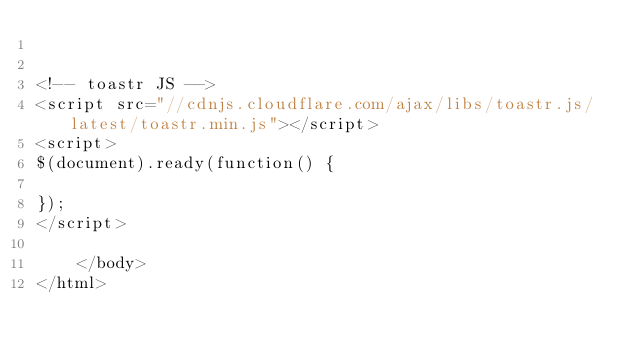Convert code to text. <code><loc_0><loc_0><loc_500><loc_500><_PHP_>

<!-- toastr JS -->
<script src="//cdnjs.cloudflare.com/ajax/libs/toastr.js/latest/toastr.min.js"></script>
<script>
$(document).ready(function() {

});
</script>

    </body>
</html>
</code> 